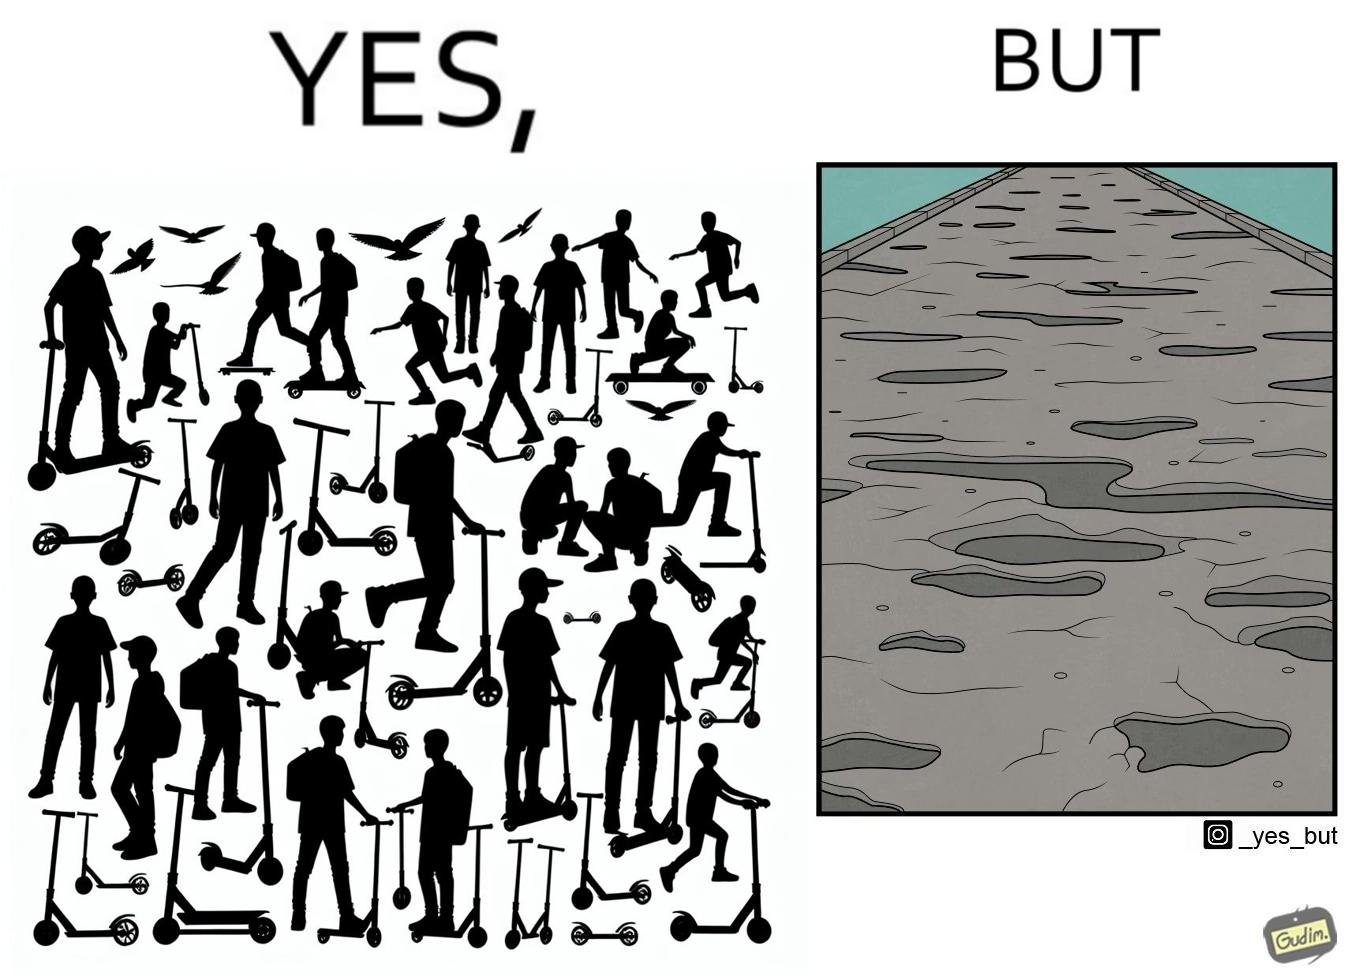Describe what you see in the left and right parts of this image. In the left part of the image: many skateboard scooters parked together In the right part of the image: a straight road with many potholes 